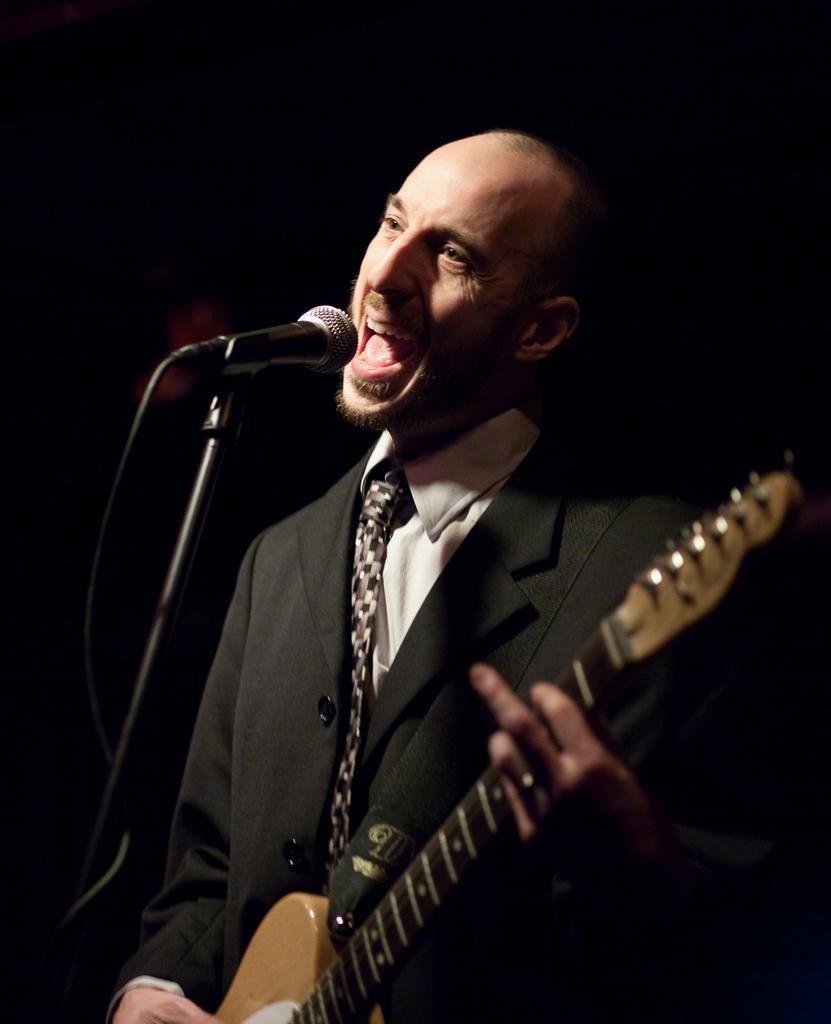Who is the main subject in the image? There is a man in the image. What is the man wearing? The man is wearing a black suit and a white shirt. What is the man doing in the image? The man is playing a guitar and singing. What object is present in the image that is related to the man's singing? There is a microphone in the image. Can you tell me how many owls are sitting on the man's shoulder in the image? There are no owls present in the image; the man is playing a guitar and singing. What type of stew is the man cooking in the image? There is no stew or cooking activity depicted in the image; the man is playing a guitar and singing. 